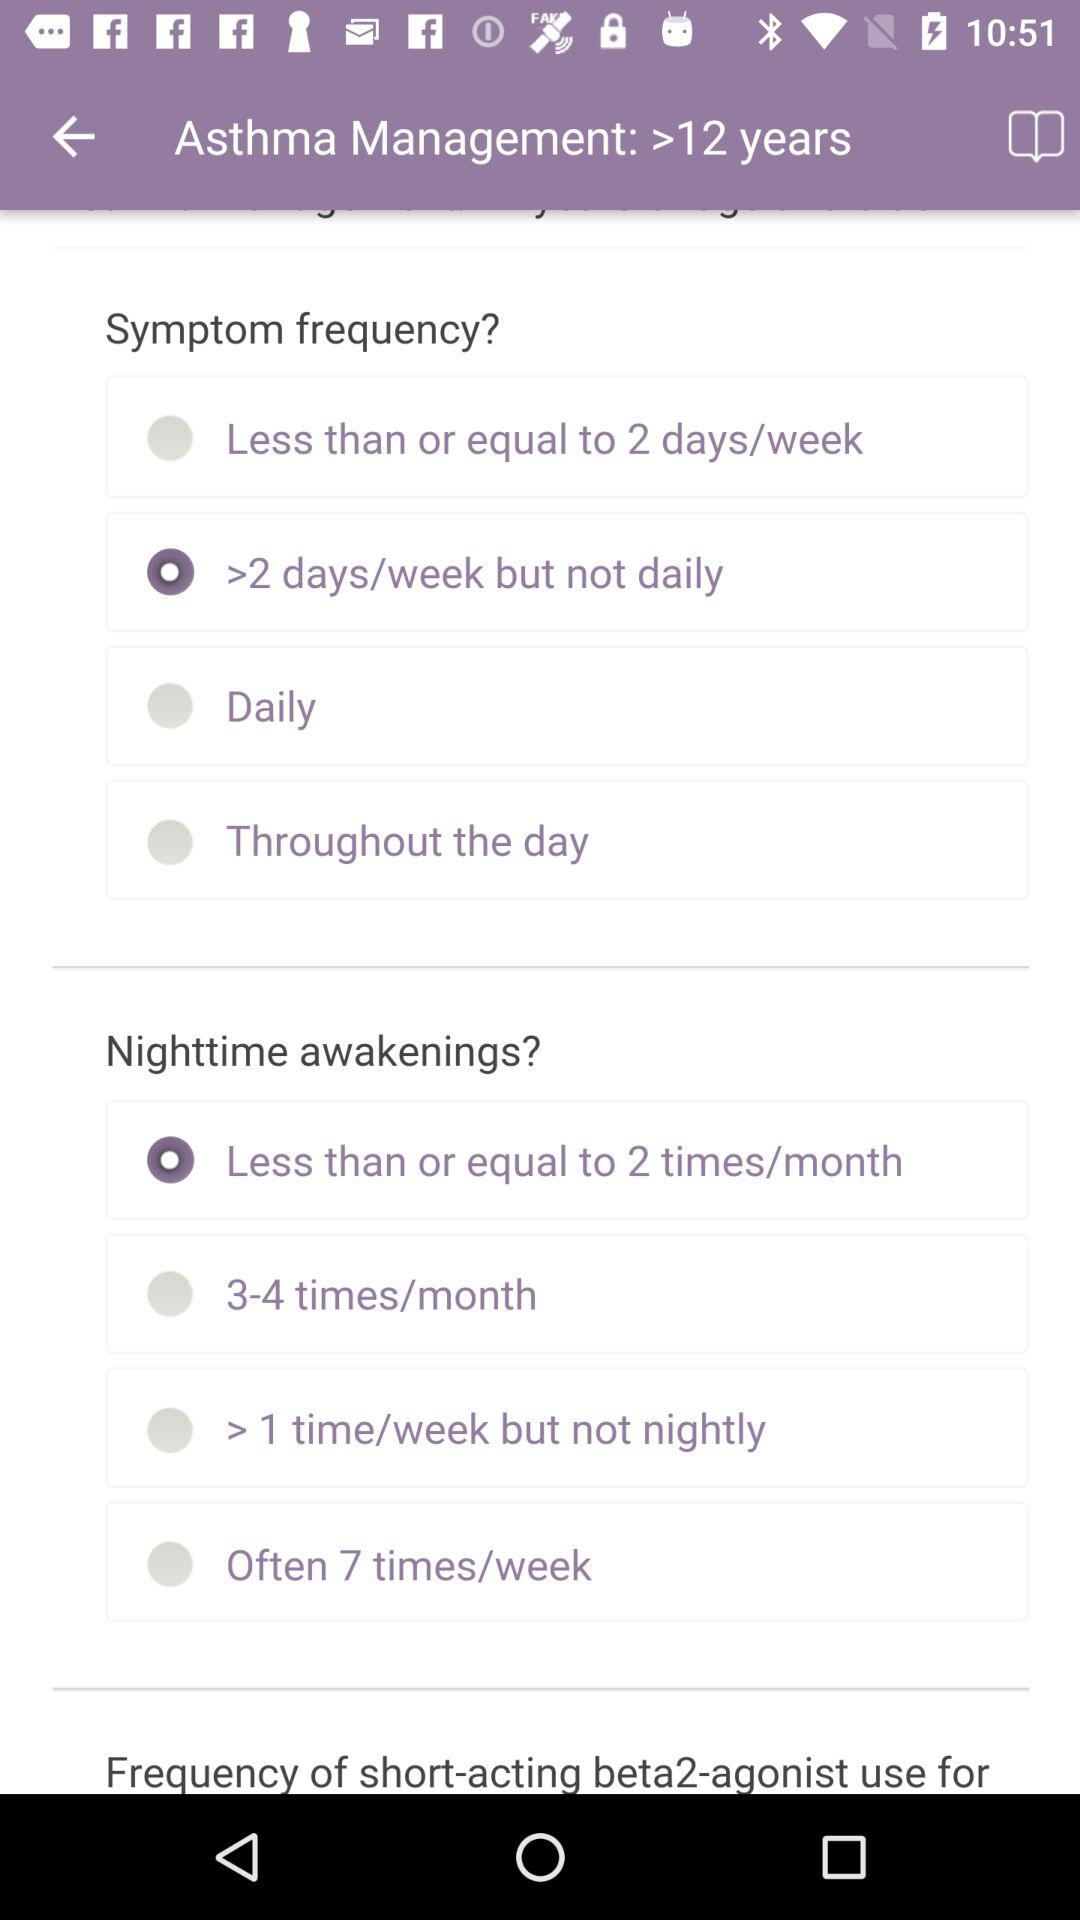What is the selected symptom frequency? The selected symptom frequency is ">2 days/week but not daily". 